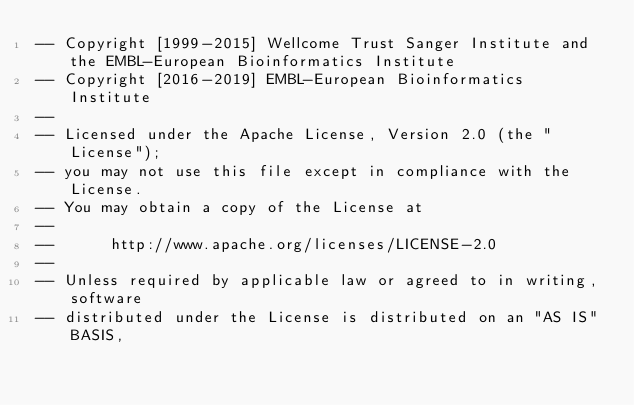<code> <loc_0><loc_0><loc_500><loc_500><_SQL_>-- Copyright [1999-2015] Wellcome Trust Sanger Institute and the EMBL-European Bioinformatics Institute
-- Copyright [2016-2019] EMBL-European Bioinformatics Institute
-- 
-- Licensed under the Apache License, Version 2.0 (the "License");
-- you may not use this file except in compliance with the License.
-- You may obtain a copy of the License at
-- 
--      http://www.apache.org/licenses/LICENSE-2.0
-- 
-- Unless required by applicable law or agreed to in writing, software
-- distributed under the License is distributed on an "AS IS" BASIS,</code> 